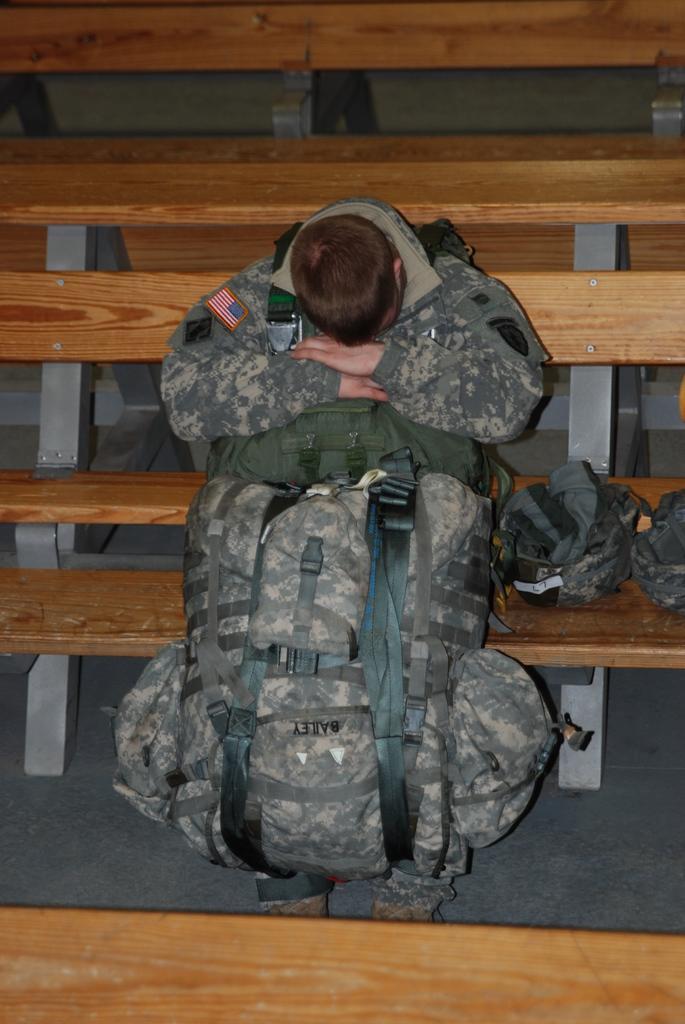In one or two sentences, can you explain what this image depicts? In the middle of the image a man is sitting and holding a bag. 